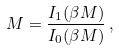<formula> <loc_0><loc_0><loc_500><loc_500>M = \frac { I _ { 1 } ( \beta M ) } { I _ { 0 } ( \beta M ) } \, ,</formula> 